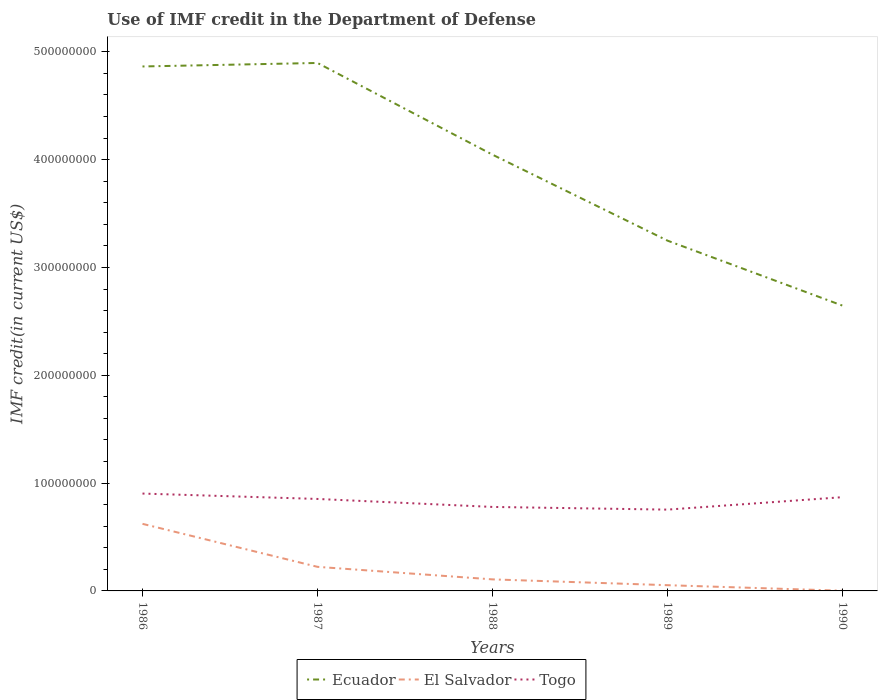Is the number of lines equal to the number of legend labels?
Offer a very short reply. Yes. Across all years, what is the maximum IMF credit in the Department of Defense in Ecuador?
Make the answer very short. 2.65e+08. In which year was the IMF credit in the Department of Defense in Togo maximum?
Offer a very short reply. 1989. What is the total IMF credit in the Department of Defense in Ecuador in the graph?
Your answer should be compact. 1.40e+08. What is the difference between the highest and the second highest IMF credit in the Department of Defense in Togo?
Offer a terse response. 1.49e+07. Is the IMF credit in the Department of Defense in Ecuador strictly greater than the IMF credit in the Department of Defense in Togo over the years?
Offer a very short reply. No. How many lines are there?
Provide a succinct answer. 3. Does the graph contain any zero values?
Your answer should be compact. No. Does the graph contain grids?
Offer a very short reply. No. Where does the legend appear in the graph?
Give a very brief answer. Bottom center. How many legend labels are there?
Your answer should be compact. 3. What is the title of the graph?
Keep it short and to the point. Use of IMF credit in the Department of Defense. Does "Myanmar" appear as one of the legend labels in the graph?
Provide a short and direct response. No. What is the label or title of the Y-axis?
Keep it short and to the point. IMF credit(in current US$). What is the IMF credit(in current US$) in Ecuador in 1986?
Provide a short and direct response. 4.86e+08. What is the IMF credit(in current US$) in El Salvador in 1986?
Provide a succinct answer. 6.22e+07. What is the IMF credit(in current US$) in Togo in 1986?
Ensure brevity in your answer.  9.03e+07. What is the IMF credit(in current US$) of Ecuador in 1987?
Ensure brevity in your answer.  4.90e+08. What is the IMF credit(in current US$) of El Salvador in 1987?
Offer a terse response. 2.23e+07. What is the IMF credit(in current US$) of Togo in 1987?
Provide a short and direct response. 8.53e+07. What is the IMF credit(in current US$) in Ecuador in 1988?
Offer a very short reply. 4.05e+08. What is the IMF credit(in current US$) in El Salvador in 1988?
Make the answer very short. 1.07e+07. What is the IMF credit(in current US$) in Togo in 1988?
Offer a very short reply. 7.79e+07. What is the IMF credit(in current US$) in Ecuador in 1989?
Offer a very short reply. 3.25e+08. What is the IMF credit(in current US$) in El Salvador in 1989?
Offer a terse response. 5.32e+06. What is the IMF credit(in current US$) of Togo in 1989?
Your answer should be compact. 7.54e+07. What is the IMF credit(in current US$) in Ecuador in 1990?
Your response must be concise. 2.65e+08. What is the IMF credit(in current US$) of El Salvador in 1990?
Your response must be concise. 1.88e+05. What is the IMF credit(in current US$) in Togo in 1990?
Your answer should be very brief. 8.70e+07. Across all years, what is the maximum IMF credit(in current US$) of Ecuador?
Offer a terse response. 4.90e+08. Across all years, what is the maximum IMF credit(in current US$) in El Salvador?
Keep it short and to the point. 6.22e+07. Across all years, what is the maximum IMF credit(in current US$) in Togo?
Provide a short and direct response. 9.03e+07. Across all years, what is the minimum IMF credit(in current US$) of Ecuador?
Your response must be concise. 2.65e+08. Across all years, what is the minimum IMF credit(in current US$) of El Salvador?
Offer a very short reply. 1.88e+05. Across all years, what is the minimum IMF credit(in current US$) of Togo?
Give a very brief answer. 7.54e+07. What is the total IMF credit(in current US$) of Ecuador in the graph?
Your answer should be very brief. 1.97e+09. What is the total IMF credit(in current US$) in El Salvador in the graph?
Make the answer very short. 1.01e+08. What is the total IMF credit(in current US$) in Togo in the graph?
Your answer should be compact. 4.16e+08. What is the difference between the IMF credit(in current US$) in Ecuador in 1986 and that in 1987?
Provide a succinct answer. -3.25e+06. What is the difference between the IMF credit(in current US$) of El Salvador in 1986 and that in 1987?
Offer a terse response. 3.99e+07. What is the difference between the IMF credit(in current US$) of Togo in 1986 and that in 1987?
Your answer should be very brief. 4.99e+06. What is the difference between the IMF credit(in current US$) of Ecuador in 1986 and that in 1988?
Keep it short and to the point. 8.18e+07. What is the difference between the IMF credit(in current US$) in El Salvador in 1986 and that in 1988?
Ensure brevity in your answer.  5.15e+07. What is the difference between the IMF credit(in current US$) of Togo in 1986 and that in 1988?
Provide a succinct answer. 1.24e+07. What is the difference between the IMF credit(in current US$) of Ecuador in 1986 and that in 1989?
Your answer should be compact. 1.62e+08. What is the difference between the IMF credit(in current US$) in El Salvador in 1986 and that in 1989?
Ensure brevity in your answer.  5.69e+07. What is the difference between the IMF credit(in current US$) in Togo in 1986 and that in 1989?
Make the answer very short. 1.49e+07. What is the difference between the IMF credit(in current US$) in Ecuador in 1986 and that in 1990?
Offer a terse response. 2.22e+08. What is the difference between the IMF credit(in current US$) of El Salvador in 1986 and that in 1990?
Your answer should be very brief. 6.20e+07. What is the difference between the IMF credit(in current US$) of Togo in 1986 and that in 1990?
Ensure brevity in your answer.  3.34e+06. What is the difference between the IMF credit(in current US$) in Ecuador in 1987 and that in 1988?
Your answer should be compact. 8.51e+07. What is the difference between the IMF credit(in current US$) in El Salvador in 1987 and that in 1988?
Your answer should be compact. 1.16e+07. What is the difference between the IMF credit(in current US$) of Togo in 1987 and that in 1988?
Your response must be concise. 7.41e+06. What is the difference between the IMF credit(in current US$) of Ecuador in 1987 and that in 1989?
Offer a terse response. 1.65e+08. What is the difference between the IMF credit(in current US$) of El Salvador in 1987 and that in 1989?
Make the answer very short. 1.70e+07. What is the difference between the IMF credit(in current US$) of Togo in 1987 and that in 1989?
Provide a succinct answer. 9.90e+06. What is the difference between the IMF credit(in current US$) in Ecuador in 1987 and that in 1990?
Ensure brevity in your answer.  2.25e+08. What is the difference between the IMF credit(in current US$) in El Salvador in 1987 and that in 1990?
Provide a succinct answer. 2.21e+07. What is the difference between the IMF credit(in current US$) in Togo in 1987 and that in 1990?
Make the answer very short. -1.64e+06. What is the difference between the IMF credit(in current US$) in Ecuador in 1988 and that in 1989?
Provide a succinct answer. 7.97e+07. What is the difference between the IMF credit(in current US$) of El Salvador in 1988 and that in 1989?
Your answer should be compact. 5.39e+06. What is the difference between the IMF credit(in current US$) in Togo in 1988 and that in 1989?
Your answer should be very brief. 2.49e+06. What is the difference between the IMF credit(in current US$) of Ecuador in 1988 and that in 1990?
Make the answer very short. 1.40e+08. What is the difference between the IMF credit(in current US$) in El Salvador in 1988 and that in 1990?
Offer a very short reply. 1.05e+07. What is the difference between the IMF credit(in current US$) in Togo in 1988 and that in 1990?
Give a very brief answer. -9.06e+06. What is the difference between the IMF credit(in current US$) in Ecuador in 1989 and that in 1990?
Offer a terse response. 6.03e+07. What is the difference between the IMF credit(in current US$) in El Salvador in 1989 and that in 1990?
Offer a very short reply. 5.13e+06. What is the difference between the IMF credit(in current US$) of Togo in 1989 and that in 1990?
Your response must be concise. -1.15e+07. What is the difference between the IMF credit(in current US$) of Ecuador in 1986 and the IMF credit(in current US$) of El Salvador in 1987?
Offer a terse response. 4.64e+08. What is the difference between the IMF credit(in current US$) of Ecuador in 1986 and the IMF credit(in current US$) of Togo in 1987?
Your answer should be very brief. 4.01e+08. What is the difference between the IMF credit(in current US$) of El Salvador in 1986 and the IMF credit(in current US$) of Togo in 1987?
Your answer should be compact. -2.31e+07. What is the difference between the IMF credit(in current US$) of Ecuador in 1986 and the IMF credit(in current US$) of El Salvador in 1988?
Keep it short and to the point. 4.76e+08. What is the difference between the IMF credit(in current US$) of Ecuador in 1986 and the IMF credit(in current US$) of Togo in 1988?
Give a very brief answer. 4.09e+08. What is the difference between the IMF credit(in current US$) in El Salvador in 1986 and the IMF credit(in current US$) in Togo in 1988?
Provide a short and direct response. -1.57e+07. What is the difference between the IMF credit(in current US$) of Ecuador in 1986 and the IMF credit(in current US$) of El Salvador in 1989?
Your response must be concise. 4.81e+08. What is the difference between the IMF credit(in current US$) in Ecuador in 1986 and the IMF credit(in current US$) in Togo in 1989?
Offer a very short reply. 4.11e+08. What is the difference between the IMF credit(in current US$) of El Salvador in 1986 and the IMF credit(in current US$) of Togo in 1989?
Offer a terse response. -1.32e+07. What is the difference between the IMF credit(in current US$) of Ecuador in 1986 and the IMF credit(in current US$) of El Salvador in 1990?
Your answer should be compact. 4.86e+08. What is the difference between the IMF credit(in current US$) in Ecuador in 1986 and the IMF credit(in current US$) in Togo in 1990?
Make the answer very short. 3.99e+08. What is the difference between the IMF credit(in current US$) in El Salvador in 1986 and the IMF credit(in current US$) in Togo in 1990?
Your answer should be very brief. -2.47e+07. What is the difference between the IMF credit(in current US$) in Ecuador in 1987 and the IMF credit(in current US$) in El Salvador in 1988?
Ensure brevity in your answer.  4.79e+08. What is the difference between the IMF credit(in current US$) in Ecuador in 1987 and the IMF credit(in current US$) in Togo in 1988?
Ensure brevity in your answer.  4.12e+08. What is the difference between the IMF credit(in current US$) in El Salvador in 1987 and the IMF credit(in current US$) in Togo in 1988?
Your response must be concise. -5.56e+07. What is the difference between the IMF credit(in current US$) of Ecuador in 1987 and the IMF credit(in current US$) of El Salvador in 1989?
Offer a terse response. 4.84e+08. What is the difference between the IMF credit(in current US$) of Ecuador in 1987 and the IMF credit(in current US$) of Togo in 1989?
Provide a short and direct response. 4.14e+08. What is the difference between the IMF credit(in current US$) in El Salvador in 1987 and the IMF credit(in current US$) in Togo in 1989?
Your answer should be very brief. -5.31e+07. What is the difference between the IMF credit(in current US$) of Ecuador in 1987 and the IMF credit(in current US$) of El Salvador in 1990?
Make the answer very short. 4.90e+08. What is the difference between the IMF credit(in current US$) in Ecuador in 1987 and the IMF credit(in current US$) in Togo in 1990?
Your response must be concise. 4.03e+08. What is the difference between the IMF credit(in current US$) in El Salvador in 1987 and the IMF credit(in current US$) in Togo in 1990?
Ensure brevity in your answer.  -6.46e+07. What is the difference between the IMF credit(in current US$) of Ecuador in 1988 and the IMF credit(in current US$) of El Salvador in 1989?
Make the answer very short. 3.99e+08. What is the difference between the IMF credit(in current US$) in Ecuador in 1988 and the IMF credit(in current US$) in Togo in 1989?
Keep it short and to the point. 3.29e+08. What is the difference between the IMF credit(in current US$) of El Salvador in 1988 and the IMF credit(in current US$) of Togo in 1989?
Offer a terse response. -6.47e+07. What is the difference between the IMF credit(in current US$) of Ecuador in 1988 and the IMF credit(in current US$) of El Salvador in 1990?
Provide a succinct answer. 4.04e+08. What is the difference between the IMF credit(in current US$) of Ecuador in 1988 and the IMF credit(in current US$) of Togo in 1990?
Keep it short and to the point. 3.18e+08. What is the difference between the IMF credit(in current US$) of El Salvador in 1988 and the IMF credit(in current US$) of Togo in 1990?
Provide a short and direct response. -7.62e+07. What is the difference between the IMF credit(in current US$) of Ecuador in 1989 and the IMF credit(in current US$) of El Salvador in 1990?
Provide a short and direct response. 3.25e+08. What is the difference between the IMF credit(in current US$) in Ecuador in 1989 and the IMF credit(in current US$) in Togo in 1990?
Your answer should be compact. 2.38e+08. What is the difference between the IMF credit(in current US$) of El Salvador in 1989 and the IMF credit(in current US$) of Togo in 1990?
Ensure brevity in your answer.  -8.16e+07. What is the average IMF credit(in current US$) in Ecuador per year?
Provide a succinct answer. 3.94e+08. What is the average IMF credit(in current US$) in El Salvador per year?
Your response must be concise. 2.02e+07. What is the average IMF credit(in current US$) in Togo per year?
Your answer should be compact. 8.32e+07. In the year 1986, what is the difference between the IMF credit(in current US$) in Ecuador and IMF credit(in current US$) in El Salvador?
Give a very brief answer. 4.24e+08. In the year 1986, what is the difference between the IMF credit(in current US$) of Ecuador and IMF credit(in current US$) of Togo?
Provide a succinct answer. 3.96e+08. In the year 1986, what is the difference between the IMF credit(in current US$) of El Salvador and IMF credit(in current US$) of Togo?
Ensure brevity in your answer.  -2.81e+07. In the year 1987, what is the difference between the IMF credit(in current US$) of Ecuador and IMF credit(in current US$) of El Salvador?
Make the answer very short. 4.67e+08. In the year 1987, what is the difference between the IMF credit(in current US$) of Ecuador and IMF credit(in current US$) of Togo?
Offer a very short reply. 4.04e+08. In the year 1987, what is the difference between the IMF credit(in current US$) of El Salvador and IMF credit(in current US$) of Togo?
Offer a very short reply. -6.30e+07. In the year 1988, what is the difference between the IMF credit(in current US$) in Ecuador and IMF credit(in current US$) in El Salvador?
Offer a very short reply. 3.94e+08. In the year 1988, what is the difference between the IMF credit(in current US$) of Ecuador and IMF credit(in current US$) of Togo?
Keep it short and to the point. 3.27e+08. In the year 1988, what is the difference between the IMF credit(in current US$) of El Salvador and IMF credit(in current US$) of Togo?
Make the answer very short. -6.72e+07. In the year 1989, what is the difference between the IMF credit(in current US$) of Ecuador and IMF credit(in current US$) of El Salvador?
Make the answer very short. 3.20e+08. In the year 1989, what is the difference between the IMF credit(in current US$) in Ecuador and IMF credit(in current US$) in Togo?
Provide a succinct answer. 2.49e+08. In the year 1989, what is the difference between the IMF credit(in current US$) in El Salvador and IMF credit(in current US$) in Togo?
Make the answer very short. -7.01e+07. In the year 1990, what is the difference between the IMF credit(in current US$) in Ecuador and IMF credit(in current US$) in El Salvador?
Give a very brief answer. 2.64e+08. In the year 1990, what is the difference between the IMF credit(in current US$) in Ecuador and IMF credit(in current US$) in Togo?
Your answer should be compact. 1.78e+08. In the year 1990, what is the difference between the IMF credit(in current US$) in El Salvador and IMF credit(in current US$) in Togo?
Make the answer very short. -8.68e+07. What is the ratio of the IMF credit(in current US$) in El Salvador in 1986 to that in 1987?
Offer a terse response. 2.79. What is the ratio of the IMF credit(in current US$) in Togo in 1986 to that in 1987?
Provide a short and direct response. 1.06. What is the ratio of the IMF credit(in current US$) of Ecuador in 1986 to that in 1988?
Offer a very short reply. 1.2. What is the ratio of the IMF credit(in current US$) in El Salvador in 1986 to that in 1988?
Give a very brief answer. 5.81. What is the ratio of the IMF credit(in current US$) in Togo in 1986 to that in 1988?
Offer a very short reply. 1.16. What is the ratio of the IMF credit(in current US$) in Ecuador in 1986 to that in 1989?
Give a very brief answer. 1.5. What is the ratio of the IMF credit(in current US$) of El Salvador in 1986 to that in 1989?
Your response must be concise. 11.7. What is the ratio of the IMF credit(in current US$) of Togo in 1986 to that in 1989?
Provide a succinct answer. 1.2. What is the ratio of the IMF credit(in current US$) in Ecuador in 1986 to that in 1990?
Offer a terse response. 1.84. What is the ratio of the IMF credit(in current US$) in El Salvador in 1986 to that in 1990?
Your answer should be compact. 330.94. What is the ratio of the IMF credit(in current US$) of Ecuador in 1987 to that in 1988?
Provide a short and direct response. 1.21. What is the ratio of the IMF credit(in current US$) in El Salvador in 1987 to that in 1988?
Give a very brief answer. 2.09. What is the ratio of the IMF credit(in current US$) of Togo in 1987 to that in 1988?
Provide a short and direct response. 1.1. What is the ratio of the IMF credit(in current US$) of Ecuador in 1987 to that in 1989?
Provide a short and direct response. 1.51. What is the ratio of the IMF credit(in current US$) in El Salvador in 1987 to that in 1989?
Offer a very short reply. 4.2. What is the ratio of the IMF credit(in current US$) of Togo in 1987 to that in 1989?
Keep it short and to the point. 1.13. What is the ratio of the IMF credit(in current US$) of Ecuador in 1987 to that in 1990?
Make the answer very short. 1.85. What is the ratio of the IMF credit(in current US$) in El Salvador in 1987 to that in 1990?
Keep it short and to the point. 118.81. What is the ratio of the IMF credit(in current US$) of Togo in 1987 to that in 1990?
Provide a succinct answer. 0.98. What is the ratio of the IMF credit(in current US$) in Ecuador in 1988 to that in 1989?
Give a very brief answer. 1.25. What is the ratio of the IMF credit(in current US$) of El Salvador in 1988 to that in 1989?
Ensure brevity in your answer.  2.01. What is the ratio of the IMF credit(in current US$) in Togo in 1988 to that in 1989?
Your response must be concise. 1.03. What is the ratio of the IMF credit(in current US$) in Ecuador in 1988 to that in 1990?
Offer a very short reply. 1.53. What is the ratio of the IMF credit(in current US$) of El Salvador in 1988 to that in 1990?
Offer a terse response. 56.96. What is the ratio of the IMF credit(in current US$) of Togo in 1988 to that in 1990?
Ensure brevity in your answer.  0.9. What is the ratio of the IMF credit(in current US$) of Ecuador in 1989 to that in 1990?
Provide a short and direct response. 1.23. What is the ratio of the IMF credit(in current US$) in El Salvador in 1989 to that in 1990?
Keep it short and to the point. 28.28. What is the ratio of the IMF credit(in current US$) in Togo in 1989 to that in 1990?
Give a very brief answer. 0.87. What is the difference between the highest and the second highest IMF credit(in current US$) in Ecuador?
Provide a succinct answer. 3.25e+06. What is the difference between the highest and the second highest IMF credit(in current US$) in El Salvador?
Your answer should be compact. 3.99e+07. What is the difference between the highest and the second highest IMF credit(in current US$) of Togo?
Give a very brief answer. 3.34e+06. What is the difference between the highest and the lowest IMF credit(in current US$) of Ecuador?
Give a very brief answer. 2.25e+08. What is the difference between the highest and the lowest IMF credit(in current US$) in El Salvador?
Your response must be concise. 6.20e+07. What is the difference between the highest and the lowest IMF credit(in current US$) in Togo?
Offer a very short reply. 1.49e+07. 